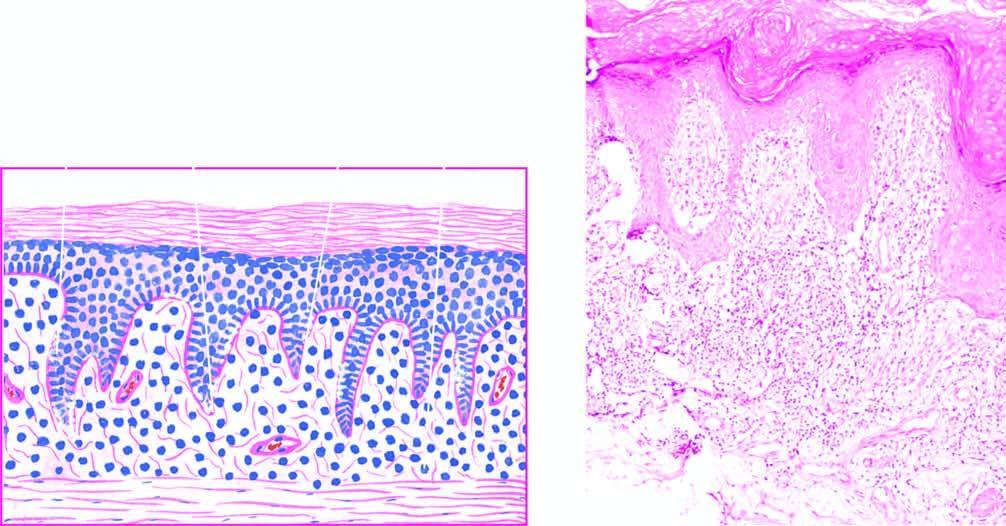what does the basal layer show?
Answer the question using a single word or phrase. Liquefactive degeneration 